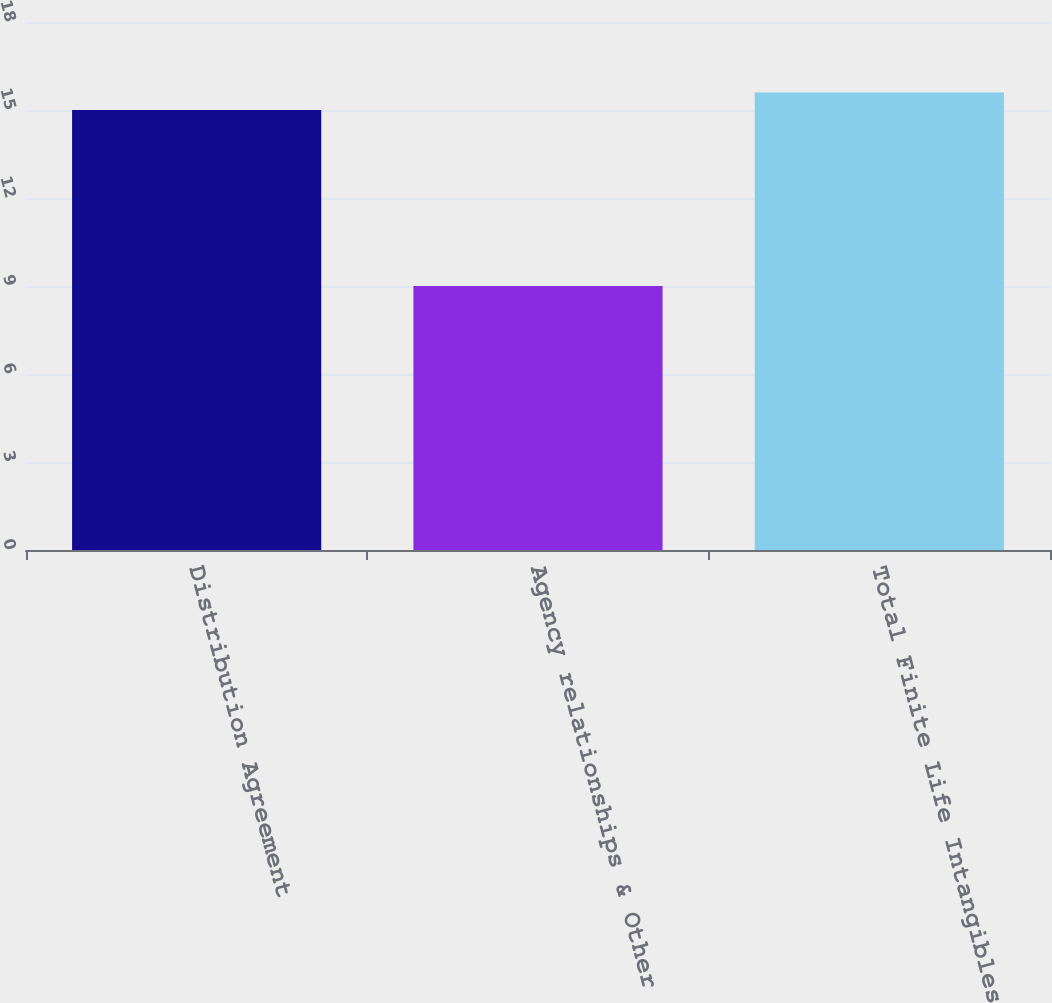Convert chart. <chart><loc_0><loc_0><loc_500><loc_500><bar_chart><fcel>Distribution Agreement<fcel>Agency relationships & Other<fcel>Total Finite Life Intangibles<nl><fcel>15<fcel>9<fcel>15.6<nl></chart> 